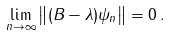<formula> <loc_0><loc_0><loc_500><loc_500>\lim _ { n \rightarrow \infty } \left \| ( B - \lambda ) \psi _ { n } \right \| = 0 \, .</formula> 